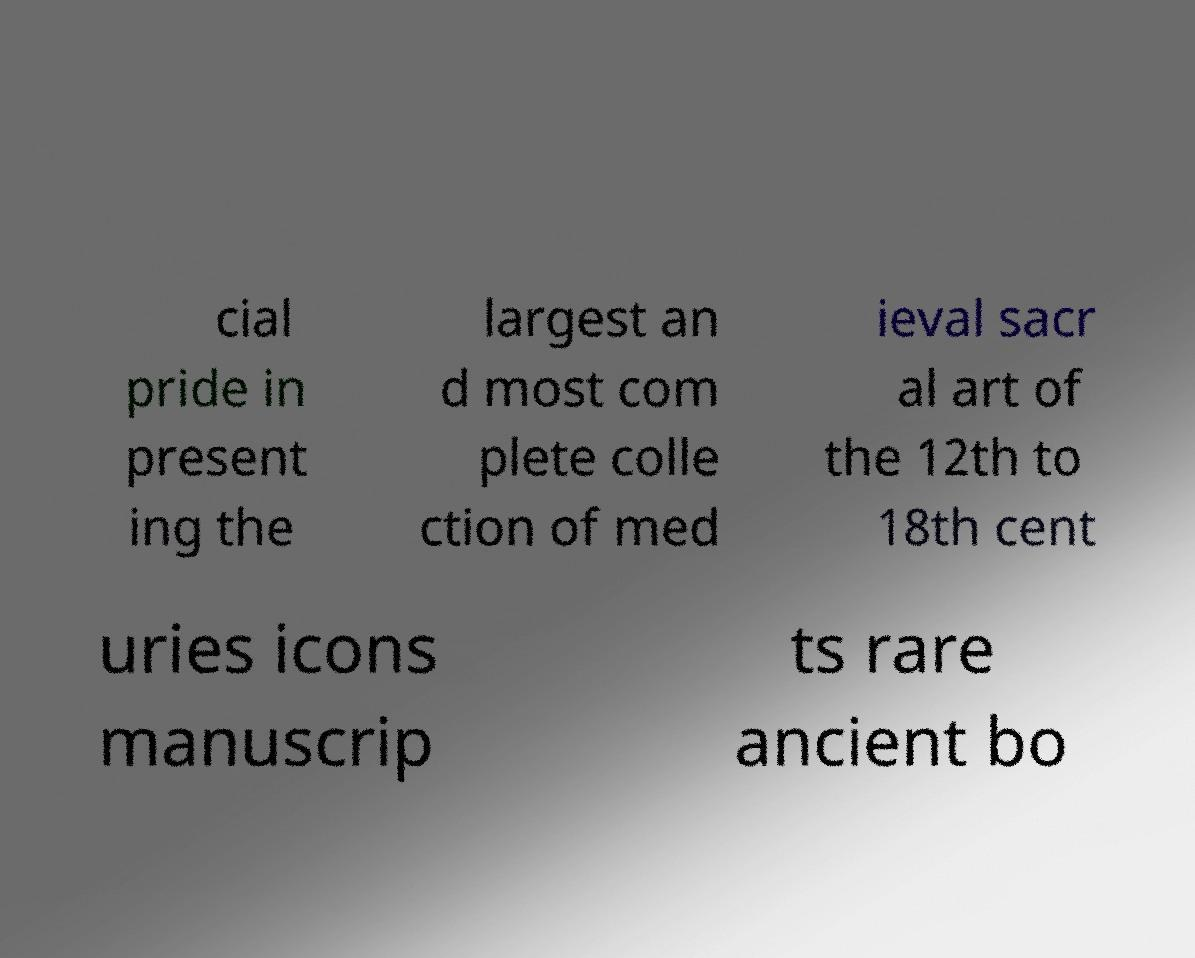Could you extract and type out the text from this image? cial pride in present ing the largest an d most com plete colle ction of med ieval sacr al art of the 12th to 18th cent uries icons manuscrip ts rare ancient bo 